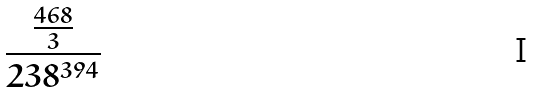Convert formula to latex. <formula><loc_0><loc_0><loc_500><loc_500>\frac { \frac { 4 6 8 } { 3 } } { 2 3 8 ^ { 3 9 4 } }</formula> 